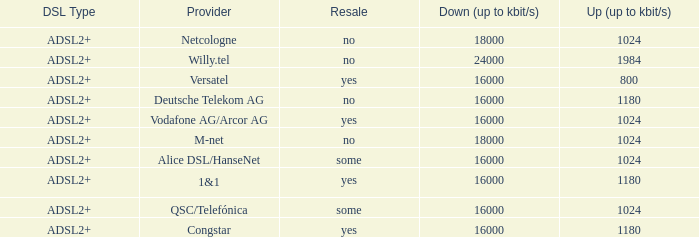What are all the dsl type offered by the M-Net telecom company? ADSL2+. 